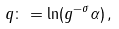Convert formula to latex. <formula><loc_0><loc_0><loc_500><loc_500>q \colon = \ln ( g ^ { - \sigma } \alpha ) \, ,</formula> 